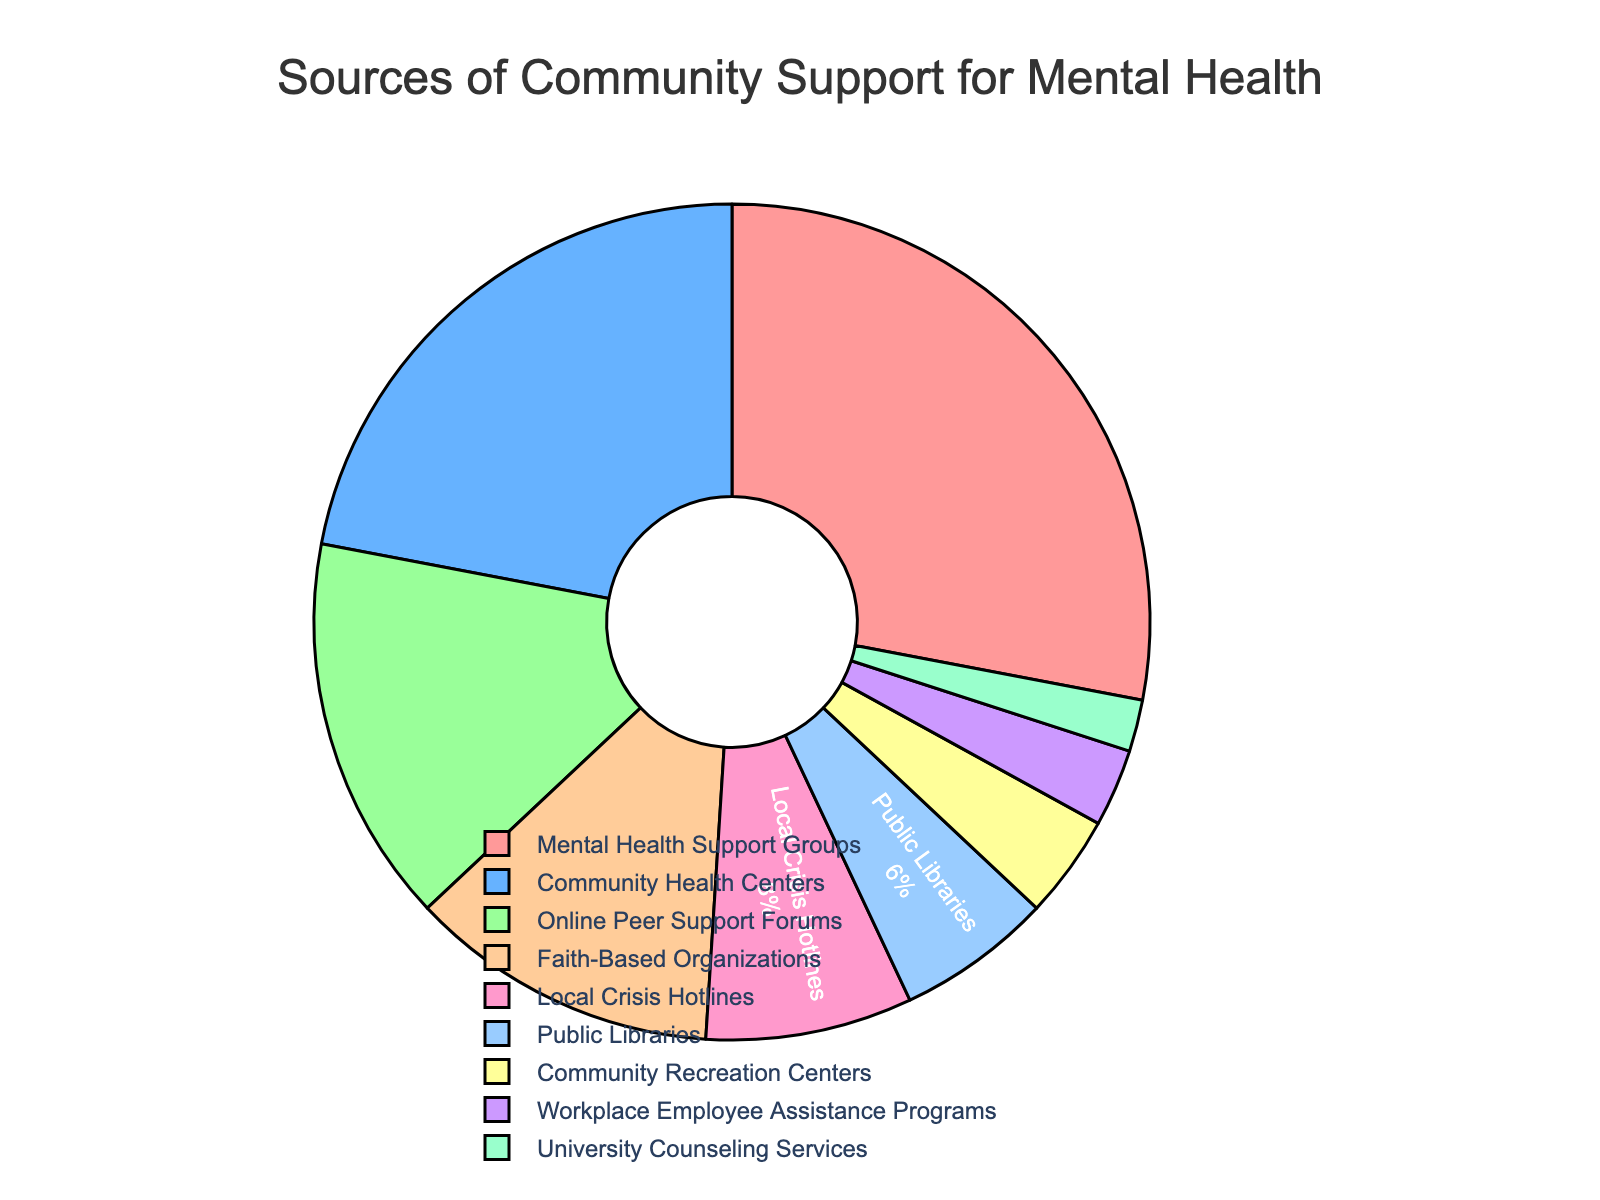Which source of community support has the highest percentage? The figure shows various sources of community support with their respective percentages. By observing the segments, Mental Health Support Groups have the highest percentage.
Answer: Mental Health Support Groups Which source has the smallest percentage? The smallest segment in the pie chart corresponds to the 2% share, which is University Counseling Services.
Answer: University Counseling Services What is the combined percentage of Community Health Centers and Online Peer Support Forums? The chart indicates that Community Health Centers have 22% and Online Peer Support Forums have 15%. Adding these together, 22% + 15% = 37%.
Answer: 37% How much larger is the percentage of Faith-Based Organizations compared to Workplace Employee Assistance Programs? Faith-Based Organizations have a 12% share, while Workplace Employee Assistance Programs have a 3% share. The difference is 12% - 3% = 9%.
Answer: 9% Which sources together contribute to more than 50% of the support? By summing the percentages of each source, we see:
- Mental Health Support Groups: 28%
- Community Health Centers: 22%
Adding these gives us 28% + 22% = 50%. Since no single source combination beyond these two adds to more than 50%, these two sources meet the criteria.
Answer: Mental Health Support Groups and Community Health Centers Compare the percentage of support from Public Libraries to Local Crisis Hotlines. Public Libraries contribute 6%, and Local Crisis Hotlines contribute 8%. Local Crisis Hotlines provide more support than Public Libraries.
Answer: Local Crisis Hotlines What is the total percentage represented by Faith-Based Organizations, Local Crisis Hotlines, and Public Libraries combined? Adding the percentages from these sources: 12% (Faith-Based Organizations) + 8% (Local Crisis Hotlines) + 6% (Public Libraries) = 26%.
Answer: 26% If Community Recreation Centers ceased to offer support, by how much would the total support percentage decrease? Community Recreation Centers provide 4% of the support. The total support percentage would decrease by 4% if they were not providing support.
Answer: 4% Is the percentage of support from Local Crisis Hotlines greater than the percentage from Workplace Employee Assistance Programs and University Counseling Services combined? Local Crisis Hotlines provide 8%, whereas Workplace Employee Assistance Programs provide 3% and University Counseling Services provide 2%, making a combined total of 3% + 2% = 5%. Thus, 8% (Local Crisis Hotlines) is indeed greater than 5%.
Answer: Yes 